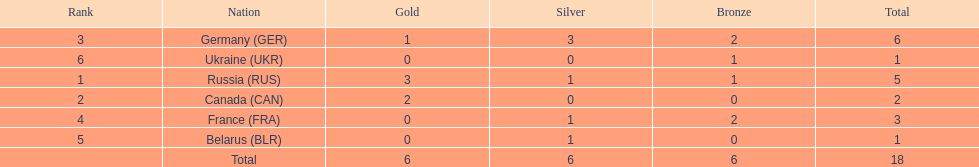What country had the most medals total at the the 1994 winter olympics biathlon? Germany (GER). 